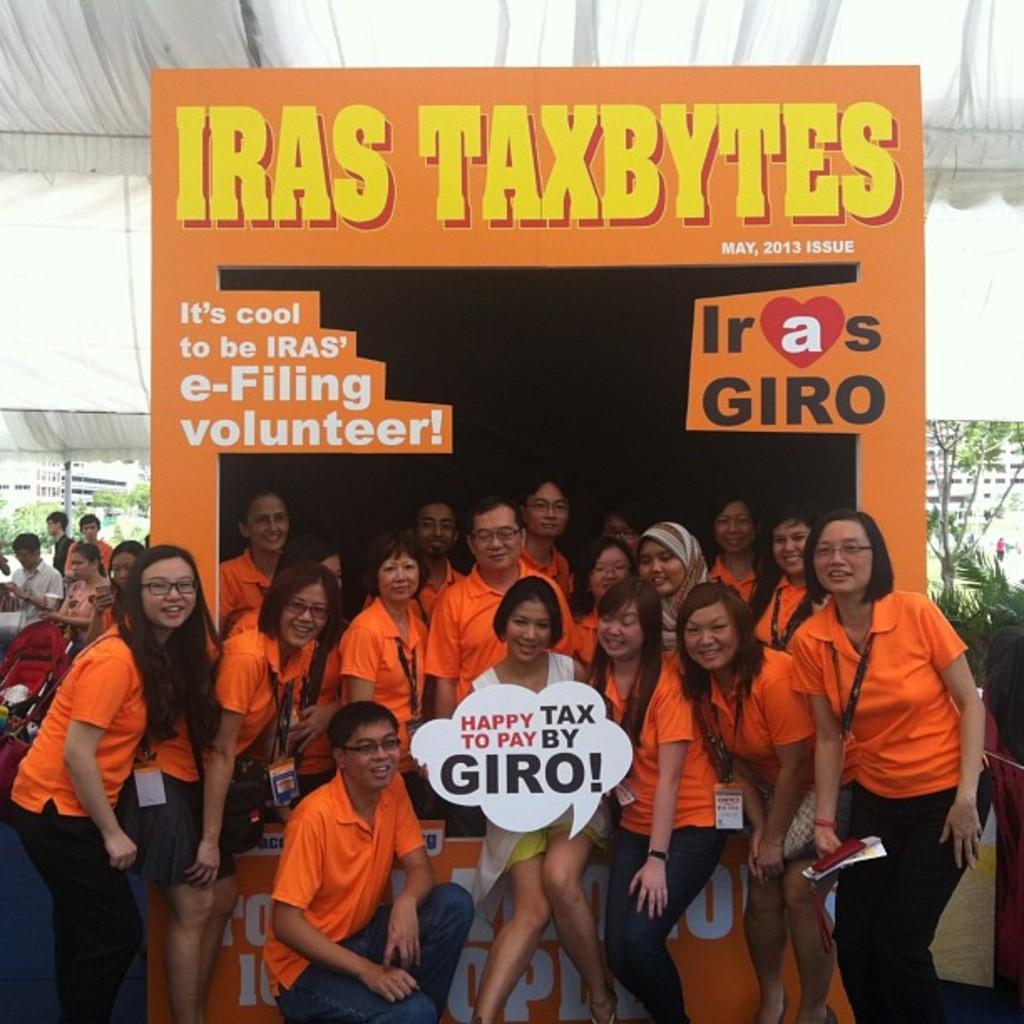Can you describe this image briefly? In this picture we can see many people wearing orange t-shirts and looking at someone. 